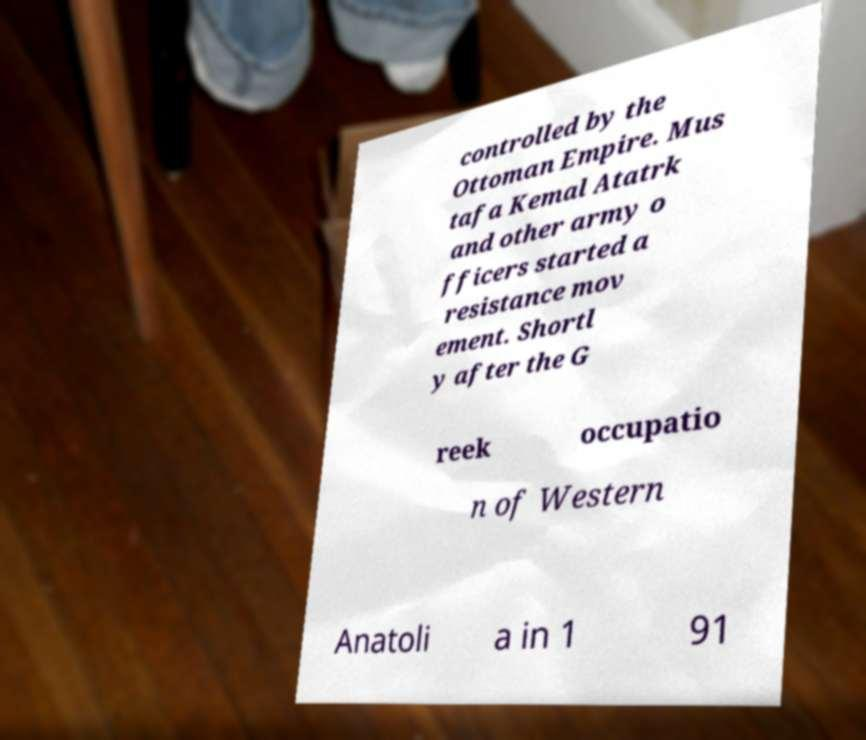What messages or text are displayed in this image? I need them in a readable, typed format. controlled by the Ottoman Empire. Mus tafa Kemal Atatrk and other army o fficers started a resistance mov ement. Shortl y after the G reek occupatio n of Western Anatoli a in 1 91 